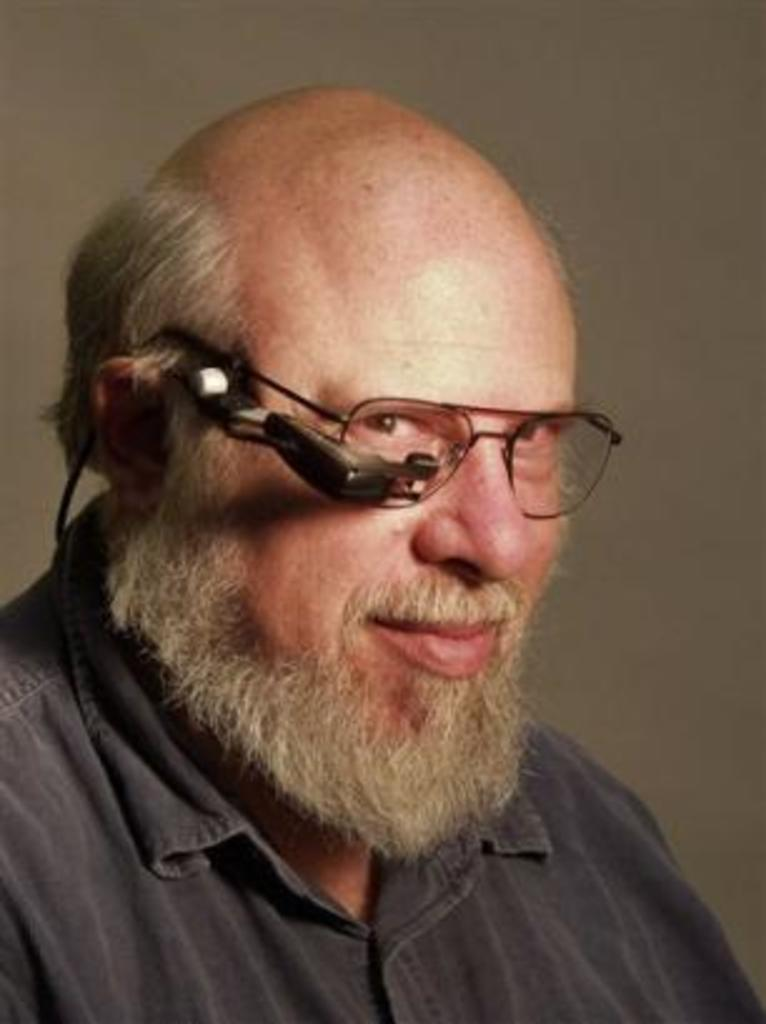What is the main subject of the image? The main subject of the image is a man. What can be observed about the man's appearance? The man is wearing spectacles. Can you describe any other objects or features in the image? There is an object near the spectacles. How many curves can be seen in the man's eyes in the image? There are no curves visible in the man's eyes in the image, as eyes do not have curves. 